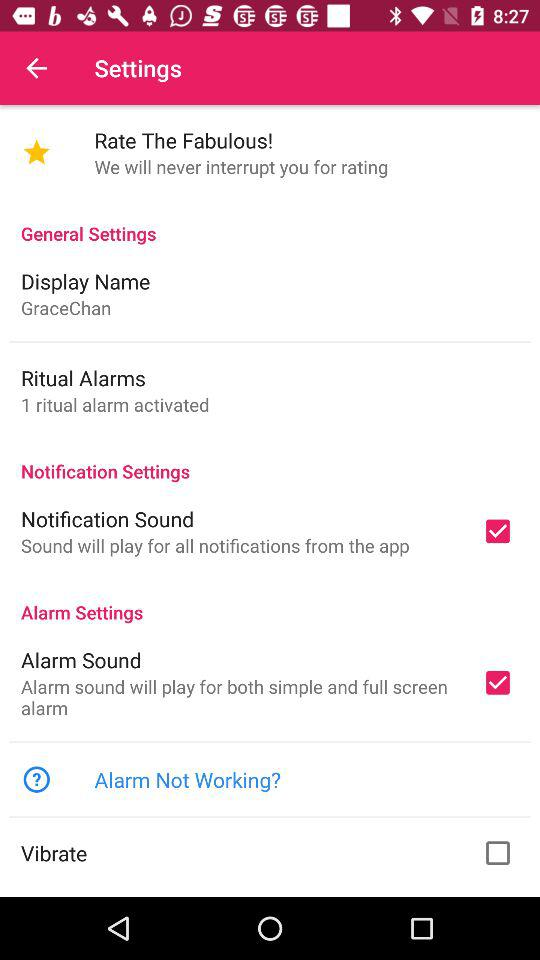What sound will be played for the simple and full-screen alarms? The sound play for the simple and full-screen alarms is the "Alarm Sound". 